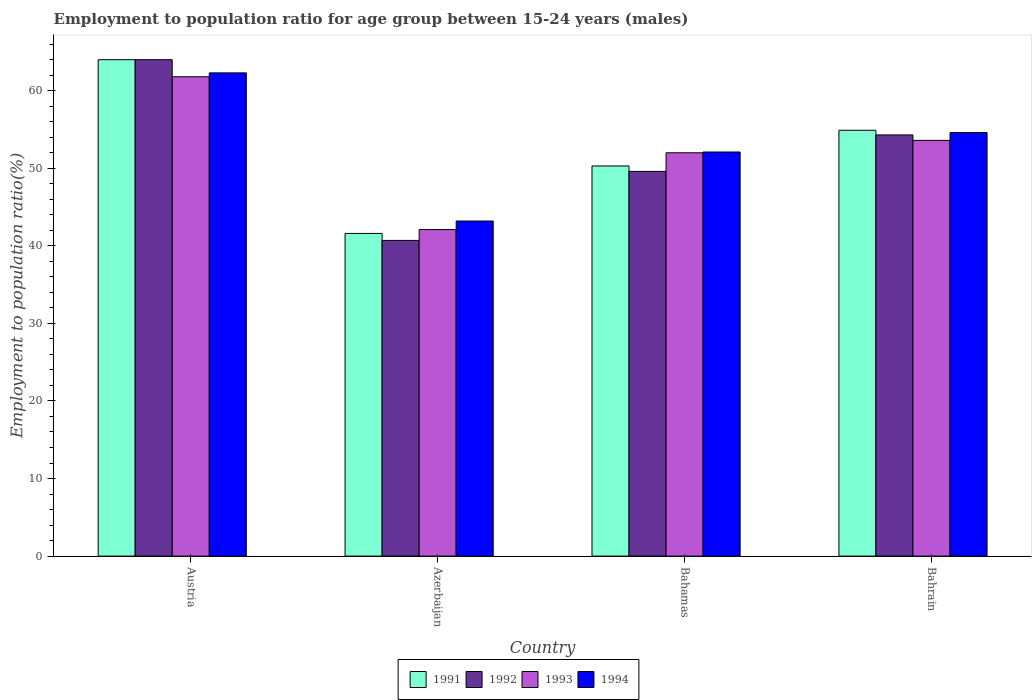How many different coloured bars are there?
Give a very brief answer. 4. What is the label of the 2nd group of bars from the left?
Your answer should be compact. Azerbaijan. In how many cases, is the number of bars for a given country not equal to the number of legend labels?
Your response must be concise. 0. What is the employment to population ratio in 1994 in Bahrain?
Offer a very short reply. 54.6. Across all countries, what is the minimum employment to population ratio in 1992?
Keep it short and to the point. 40.7. In which country was the employment to population ratio in 1994 maximum?
Provide a succinct answer. Austria. In which country was the employment to population ratio in 1992 minimum?
Make the answer very short. Azerbaijan. What is the total employment to population ratio in 1993 in the graph?
Ensure brevity in your answer.  209.5. What is the difference between the employment to population ratio in 1992 in Austria and that in Bahrain?
Give a very brief answer. 9.7. What is the difference between the employment to population ratio in 1992 in Austria and the employment to population ratio in 1993 in Azerbaijan?
Provide a succinct answer. 21.9. What is the average employment to population ratio in 1992 per country?
Provide a succinct answer. 52.15. What is the difference between the employment to population ratio of/in 1993 and employment to population ratio of/in 1991 in Austria?
Give a very brief answer. -2.2. What is the ratio of the employment to population ratio in 1994 in Austria to that in Bahrain?
Your answer should be very brief. 1.14. Is the employment to population ratio in 1992 in Azerbaijan less than that in Bahamas?
Make the answer very short. Yes. What is the difference between the highest and the second highest employment to population ratio in 1993?
Provide a succinct answer. 1.6. What is the difference between the highest and the lowest employment to population ratio in 1992?
Your answer should be compact. 23.3. In how many countries, is the employment to population ratio in 1992 greater than the average employment to population ratio in 1992 taken over all countries?
Keep it short and to the point. 2. Is the sum of the employment to population ratio in 1991 in Azerbaijan and Bahamas greater than the maximum employment to population ratio in 1994 across all countries?
Your response must be concise. Yes. How many countries are there in the graph?
Provide a short and direct response. 4. How many legend labels are there?
Your answer should be very brief. 4. What is the title of the graph?
Make the answer very short. Employment to population ratio for age group between 15-24 years (males). Does "1979" appear as one of the legend labels in the graph?
Your answer should be very brief. No. What is the Employment to population ratio(%) of 1991 in Austria?
Give a very brief answer. 64. What is the Employment to population ratio(%) of 1993 in Austria?
Your answer should be very brief. 61.8. What is the Employment to population ratio(%) of 1994 in Austria?
Make the answer very short. 62.3. What is the Employment to population ratio(%) in 1991 in Azerbaijan?
Offer a terse response. 41.6. What is the Employment to population ratio(%) in 1992 in Azerbaijan?
Your response must be concise. 40.7. What is the Employment to population ratio(%) in 1993 in Azerbaijan?
Your answer should be very brief. 42.1. What is the Employment to population ratio(%) in 1994 in Azerbaijan?
Offer a terse response. 43.2. What is the Employment to population ratio(%) of 1991 in Bahamas?
Make the answer very short. 50.3. What is the Employment to population ratio(%) in 1992 in Bahamas?
Give a very brief answer. 49.6. What is the Employment to population ratio(%) of 1994 in Bahamas?
Your answer should be very brief. 52.1. What is the Employment to population ratio(%) of 1991 in Bahrain?
Your response must be concise. 54.9. What is the Employment to population ratio(%) of 1992 in Bahrain?
Offer a very short reply. 54.3. What is the Employment to population ratio(%) in 1993 in Bahrain?
Your response must be concise. 53.6. What is the Employment to population ratio(%) in 1994 in Bahrain?
Give a very brief answer. 54.6. Across all countries, what is the maximum Employment to population ratio(%) of 1991?
Your response must be concise. 64. Across all countries, what is the maximum Employment to population ratio(%) in 1992?
Your answer should be compact. 64. Across all countries, what is the maximum Employment to population ratio(%) of 1993?
Your response must be concise. 61.8. Across all countries, what is the maximum Employment to population ratio(%) in 1994?
Your answer should be compact. 62.3. Across all countries, what is the minimum Employment to population ratio(%) of 1991?
Offer a terse response. 41.6. Across all countries, what is the minimum Employment to population ratio(%) in 1992?
Ensure brevity in your answer.  40.7. Across all countries, what is the minimum Employment to population ratio(%) in 1993?
Your response must be concise. 42.1. Across all countries, what is the minimum Employment to population ratio(%) in 1994?
Provide a short and direct response. 43.2. What is the total Employment to population ratio(%) of 1991 in the graph?
Give a very brief answer. 210.8. What is the total Employment to population ratio(%) of 1992 in the graph?
Your response must be concise. 208.6. What is the total Employment to population ratio(%) in 1993 in the graph?
Provide a succinct answer. 209.5. What is the total Employment to population ratio(%) of 1994 in the graph?
Ensure brevity in your answer.  212.2. What is the difference between the Employment to population ratio(%) of 1991 in Austria and that in Azerbaijan?
Keep it short and to the point. 22.4. What is the difference between the Employment to population ratio(%) of 1992 in Austria and that in Azerbaijan?
Provide a succinct answer. 23.3. What is the difference between the Employment to population ratio(%) in 1993 in Austria and that in Azerbaijan?
Offer a very short reply. 19.7. What is the difference between the Employment to population ratio(%) of 1993 in Austria and that in Bahamas?
Your response must be concise. 9.8. What is the difference between the Employment to population ratio(%) in 1991 in Austria and that in Bahrain?
Provide a short and direct response. 9.1. What is the difference between the Employment to population ratio(%) in 1993 in Austria and that in Bahrain?
Your answer should be very brief. 8.2. What is the difference between the Employment to population ratio(%) of 1991 in Azerbaijan and that in Bahamas?
Ensure brevity in your answer.  -8.7. What is the difference between the Employment to population ratio(%) of 1992 in Azerbaijan and that in Bahamas?
Offer a terse response. -8.9. What is the difference between the Employment to population ratio(%) of 1991 in Azerbaijan and that in Bahrain?
Your answer should be compact. -13.3. What is the difference between the Employment to population ratio(%) of 1994 in Bahamas and that in Bahrain?
Give a very brief answer. -2.5. What is the difference between the Employment to population ratio(%) in 1991 in Austria and the Employment to population ratio(%) in 1992 in Azerbaijan?
Your answer should be very brief. 23.3. What is the difference between the Employment to population ratio(%) of 1991 in Austria and the Employment to population ratio(%) of 1993 in Azerbaijan?
Offer a very short reply. 21.9. What is the difference between the Employment to population ratio(%) in 1991 in Austria and the Employment to population ratio(%) in 1994 in Azerbaijan?
Offer a very short reply. 20.8. What is the difference between the Employment to population ratio(%) in 1992 in Austria and the Employment to population ratio(%) in 1993 in Azerbaijan?
Offer a very short reply. 21.9. What is the difference between the Employment to population ratio(%) of 1992 in Austria and the Employment to population ratio(%) of 1994 in Azerbaijan?
Your answer should be very brief. 20.8. What is the difference between the Employment to population ratio(%) in 1991 in Austria and the Employment to population ratio(%) in 1993 in Bahamas?
Provide a succinct answer. 12. What is the difference between the Employment to population ratio(%) in 1991 in Austria and the Employment to population ratio(%) in 1994 in Bahamas?
Your answer should be very brief. 11.9. What is the difference between the Employment to population ratio(%) in 1992 in Austria and the Employment to population ratio(%) in 1994 in Bahamas?
Your answer should be compact. 11.9. What is the difference between the Employment to population ratio(%) in 1991 in Austria and the Employment to population ratio(%) in 1994 in Bahrain?
Ensure brevity in your answer.  9.4. What is the difference between the Employment to population ratio(%) of 1992 in Austria and the Employment to population ratio(%) of 1994 in Bahrain?
Your answer should be compact. 9.4. What is the difference between the Employment to population ratio(%) in 1992 in Azerbaijan and the Employment to population ratio(%) in 1993 in Bahamas?
Keep it short and to the point. -11.3. What is the difference between the Employment to population ratio(%) of 1992 in Azerbaijan and the Employment to population ratio(%) of 1994 in Bahamas?
Give a very brief answer. -11.4. What is the difference between the Employment to population ratio(%) of 1993 in Azerbaijan and the Employment to population ratio(%) of 1994 in Bahamas?
Your response must be concise. -10. What is the difference between the Employment to population ratio(%) of 1991 in Azerbaijan and the Employment to population ratio(%) of 1992 in Bahrain?
Your answer should be compact. -12.7. What is the difference between the Employment to population ratio(%) of 1991 in Azerbaijan and the Employment to population ratio(%) of 1993 in Bahrain?
Keep it short and to the point. -12. What is the difference between the Employment to population ratio(%) in 1991 in Azerbaijan and the Employment to population ratio(%) in 1994 in Bahrain?
Ensure brevity in your answer.  -13. What is the difference between the Employment to population ratio(%) in 1992 in Azerbaijan and the Employment to population ratio(%) in 1993 in Bahrain?
Ensure brevity in your answer.  -12.9. What is the difference between the Employment to population ratio(%) in 1991 in Bahamas and the Employment to population ratio(%) in 1992 in Bahrain?
Your answer should be very brief. -4. What is the difference between the Employment to population ratio(%) of 1993 in Bahamas and the Employment to population ratio(%) of 1994 in Bahrain?
Your response must be concise. -2.6. What is the average Employment to population ratio(%) in 1991 per country?
Your response must be concise. 52.7. What is the average Employment to population ratio(%) in 1992 per country?
Your answer should be compact. 52.15. What is the average Employment to population ratio(%) in 1993 per country?
Your answer should be very brief. 52.38. What is the average Employment to population ratio(%) in 1994 per country?
Ensure brevity in your answer.  53.05. What is the difference between the Employment to population ratio(%) of 1991 and Employment to population ratio(%) of 1992 in Austria?
Ensure brevity in your answer.  0. What is the difference between the Employment to population ratio(%) in 1991 and Employment to population ratio(%) in 1993 in Austria?
Make the answer very short. 2.2. What is the difference between the Employment to population ratio(%) of 1992 and Employment to population ratio(%) of 1993 in Austria?
Your answer should be compact. 2.2. What is the difference between the Employment to population ratio(%) in 1992 and Employment to population ratio(%) in 1994 in Austria?
Keep it short and to the point. 1.7. What is the difference between the Employment to population ratio(%) of 1991 and Employment to population ratio(%) of 1993 in Azerbaijan?
Offer a very short reply. -0.5. What is the difference between the Employment to population ratio(%) in 1992 and Employment to population ratio(%) in 1993 in Azerbaijan?
Make the answer very short. -1.4. What is the difference between the Employment to population ratio(%) of 1993 and Employment to population ratio(%) of 1994 in Azerbaijan?
Give a very brief answer. -1.1. What is the difference between the Employment to population ratio(%) in 1991 and Employment to population ratio(%) in 1992 in Bahamas?
Your answer should be compact. 0.7. What is the difference between the Employment to population ratio(%) in 1991 and Employment to population ratio(%) in 1993 in Bahamas?
Your answer should be very brief. -1.7. What is the difference between the Employment to population ratio(%) in 1991 and Employment to population ratio(%) in 1992 in Bahrain?
Provide a succinct answer. 0.6. What is the difference between the Employment to population ratio(%) in 1991 and Employment to population ratio(%) in 1993 in Bahrain?
Provide a short and direct response. 1.3. What is the difference between the Employment to population ratio(%) of 1991 and Employment to population ratio(%) of 1994 in Bahrain?
Ensure brevity in your answer.  0.3. What is the difference between the Employment to population ratio(%) of 1992 and Employment to population ratio(%) of 1993 in Bahrain?
Make the answer very short. 0.7. What is the difference between the Employment to population ratio(%) of 1992 and Employment to population ratio(%) of 1994 in Bahrain?
Your response must be concise. -0.3. What is the ratio of the Employment to population ratio(%) of 1991 in Austria to that in Azerbaijan?
Make the answer very short. 1.54. What is the ratio of the Employment to population ratio(%) in 1992 in Austria to that in Azerbaijan?
Provide a succinct answer. 1.57. What is the ratio of the Employment to population ratio(%) in 1993 in Austria to that in Azerbaijan?
Provide a short and direct response. 1.47. What is the ratio of the Employment to population ratio(%) in 1994 in Austria to that in Azerbaijan?
Your answer should be very brief. 1.44. What is the ratio of the Employment to population ratio(%) in 1991 in Austria to that in Bahamas?
Keep it short and to the point. 1.27. What is the ratio of the Employment to population ratio(%) of 1992 in Austria to that in Bahamas?
Your answer should be very brief. 1.29. What is the ratio of the Employment to population ratio(%) of 1993 in Austria to that in Bahamas?
Provide a short and direct response. 1.19. What is the ratio of the Employment to population ratio(%) of 1994 in Austria to that in Bahamas?
Keep it short and to the point. 1.2. What is the ratio of the Employment to population ratio(%) in 1991 in Austria to that in Bahrain?
Your answer should be compact. 1.17. What is the ratio of the Employment to population ratio(%) in 1992 in Austria to that in Bahrain?
Your response must be concise. 1.18. What is the ratio of the Employment to population ratio(%) of 1993 in Austria to that in Bahrain?
Offer a terse response. 1.15. What is the ratio of the Employment to population ratio(%) in 1994 in Austria to that in Bahrain?
Your answer should be compact. 1.14. What is the ratio of the Employment to population ratio(%) in 1991 in Azerbaijan to that in Bahamas?
Offer a very short reply. 0.83. What is the ratio of the Employment to population ratio(%) of 1992 in Azerbaijan to that in Bahamas?
Make the answer very short. 0.82. What is the ratio of the Employment to population ratio(%) in 1993 in Azerbaijan to that in Bahamas?
Ensure brevity in your answer.  0.81. What is the ratio of the Employment to population ratio(%) in 1994 in Azerbaijan to that in Bahamas?
Provide a succinct answer. 0.83. What is the ratio of the Employment to population ratio(%) of 1991 in Azerbaijan to that in Bahrain?
Ensure brevity in your answer.  0.76. What is the ratio of the Employment to population ratio(%) of 1992 in Azerbaijan to that in Bahrain?
Make the answer very short. 0.75. What is the ratio of the Employment to population ratio(%) of 1993 in Azerbaijan to that in Bahrain?
Provide a succinct answer. 0.79. What is the ratio of the Employment to population ratio(%) of 1994 in Azerbaijan to that in Bahrain?
Offer a terse response. 0.79. What is the ratio of the Employment to population ratio(%) in 1991 in Bahamas to that in Bahrain?
Your response must be concise. 0.92. What is the ratio of the Employment to population ratio(%) in 1992 in Bahamas to that in Bahrain?
Keep it short and to the point. 0.91. What is the ratio of the Employment to population ratio(%) of 1993 in Bahamas to that in Bahrain?
Provide a short and direct response. 0.97. What is the ratio of the Employment to population ratio(%) in 1994 in Bahamas to that in Bahrain?
Ensure brevity in your answer.  0.95. What is the difference between the highest and the second highest Employment to population ratio(%) of 1991?
Make the answer very short. 9.1. What is the difference between the highest and the second highest Employment to population ratio(%) in 1992?
Offer a very short reply. 9.7. What is the difference between the highest and the lowest Employment to population ratio(%) of 1991?
Give a very brief answer. 22.4. What is the difference between the highest and the lowest Employment to population ratio(%) in 1992?
Your answer should be very brief. 23.3. What is the difference between the highest and the lowest Employment to population ratio(%) of 1994?
Your response must be concise. 19.1. 